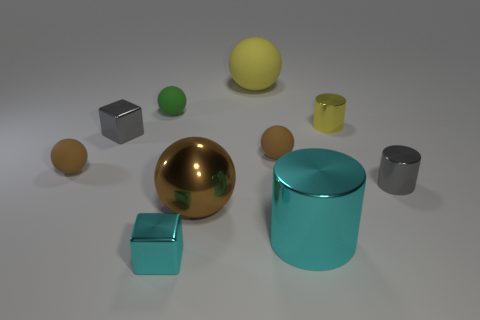There is a cyan thing behind the cyan object on the left side of the cyan object that is right of the brown shiny ball; what shape is it?
Your response must be concise. Cylinder. How many green things are big objects or matte objects?
Offer a terse response. 1. Are there the same number of tiny gray things that are in front of the big cyan metal cylinder and big cyan cylinders that are in front of the small yellow object?
Offer a very short reply. No. There is a tiny brown rubber object that is on the right side of the small cyan shiny thing; does it have the same shape as the small brown object left of the small cyan shiny block?
Keep it short and to the point. Yes. Are there any other things that have the same shape as the tiny cyan object?
Keep it short and to the point. Yes. What shape is the brown object that is made of the same material as the cyan block?
Keep it short and to the point. Sphere. Are there the same number of cyan cylinders that are to the left of the big yellow matte object and large yellow metallic blocks?
Your answer should be very brief. Yes. Do the tiny brown sphere on the left side of the tiny gray block and the small object behind the yellow cylinder have the same material?
Provide a short and direct response. Yes. There is a yellow object behind the yellow thing on the right side of the yellow matte ball; what shape is it?
Offer a very short reply. Sphere. There is a big cylinder that is the same material as the large brown sphere; what is its color?
Keep it short and to the point. Cyan. 